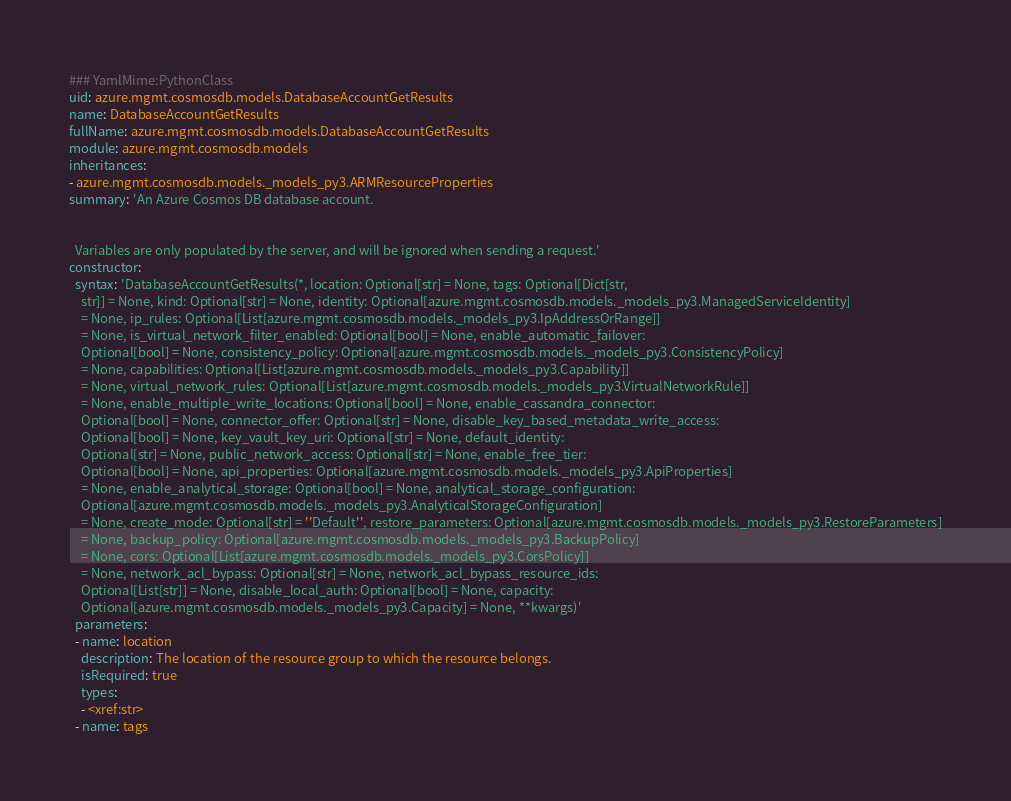<code> <loc_0><loc_0><loc_500><loc_500><_YAML_>### YamlMime:PythonClass
uid: azure.mgmt.cosmosdb.models.DatabaseAccountGetResults
name: DatabaseAccountGetResults
fullName: azure.mgmt.cosmosdb.models.DatabaseAccountGetResults
module: azure.mgmt.cosmosdb.models
inheritances:
- azure.mgmt.cosmosdb.models._models_py3.ARMResourceProperties
summary: 'An Azure Cosmos DB database account.


  Variables are only populated by the server, and will be ignored when sending a request.'
constructor:
  syntax: 'DatabaseAccountGetResults(*, location: Optional[str] = None, tags: Optional[Dict[str,
    str]] = None, kind: Optional[str] = None, identity: Optional[azure.mgmt.cosmosdb.models._models_py3.ManagedServiceIdentity]
    = None, ip_rules: Optional[List[azure.mgmt.cosmosdb.models._models_py3.IpAddressOrRange]]
    = None, is_virtual_network_filter_enabled: Optional[bool] = None, enable_automatic_failover:
    Optional[bool] = None, consistency_policy: Optional[azure.mgmt.cosmosdb.models._models_py3.ConsistencyPolicy]
    = None, capabilities: Optional[List[azure.mgmt.cosmosdb.models._models_py3.Capability]]
    = None, virtual_network_rules: Optional[List[azure.mgmt.cosmosdb.models._models_py3.VirtualNetworkRule]]
    = None, enable_multiple_write_locations: Optional[bool] = None, enable_cassandra_connector:
    Optional[bool] = None, connector_offer: Optional[str] = None, disable_key_based_metadata_write_access:
    Optional[bool] = None, key_vault_key_uri: Optional[str] = None, default_identity:
    Optional[str] = None, public_network_access: Optional[str] = None, enable_free_tier:
    Optional[bool] = None, api_properties: Optional[azure.mgmt.cosmosdb.models._models_py3.ApiProperties]
    = None, enable_analytical_storage: Optional[bool] = None, analytical_storage_configuration:
    Optional[azure.mgmt.cosmosdb.models._models_py3.AnalyticalStorageConfiguration]
    = None, create_mode: Optional[str] = ''Default'', restore_parameters: Optional[azure.mgmt.cosmosdb.models._models_py3.RestoreParameters]
    = None, backup_policy: Optional[azure.mgmt.cosmosdb.models._models_py3.BackupPolicy]
    = None, cors: Optional[List[azure.mgmt.cosmosdb.models._models_py3.CorsPolicy]]
    = None, network_acl_bypass: Optional[str] = None, network_acl_bypass_resource_ids:
    Optional[List[str]] = None, disable_local_auth: Optional[bool] = None, capacity:
    Optional[azure.mgmt.cosmosdb.models._models_py3.Capacity] = None, **kwargs)'
  parameters:
  - name: location
    description: The location of the resource group to which the resource belongs.
    isRequired: true
    types:
    - <xref:str>
  - name: tags</code> 